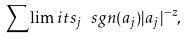<formula> <loc_0><loc_0><loc_500><loc_500>\sum \lim i t s _ { j } \ s g n ( a _ { j } ) | a _ { j } | ^ { - z } ,</formula> 